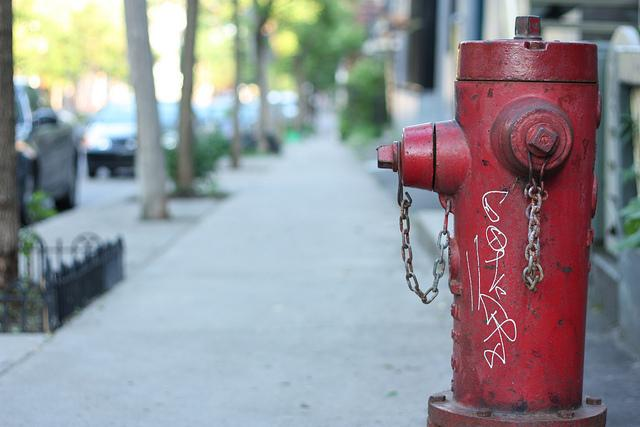Why are there chains on the red thing? Please explain your reasoning. hold lids. The chains hold lids. 